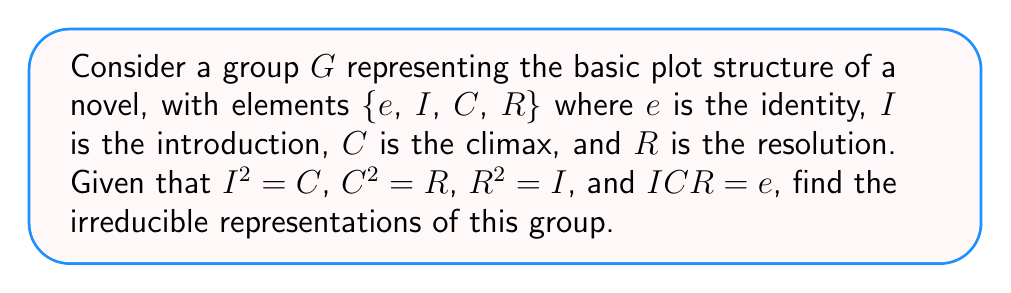Help me with this question. 1) First, we need to determine the order of the group. The group $G$ has 4 elements, so $|G| = 4$.

2) Next, we need to find the conjugacy classes of $G$. Since $G$ is abelian (all elements commute), each element forms its own conjugacy class. So we have 4 conjugacy classes: $\{e\}$, $\{I\}$, $\{C\}$, and $\{R\}$.

3) The number of irreducible representations is equal to the number of conjugacy classes. Therefore, $G$ has 4 irreducible representations.

4) For an abelian group, all irreducible representations are 1-dimensional. This is because the commutator subgroup is trivial.

5) We can construct these representations as follows:
   
   $\chi_1$: The trivial representation, where every element maps to 1.
   
   $\chi_2$: $\chi_2(e) = 1$, $\chi_2(I) = i$, $\chi_2(C) = -1$, $\chi_2(R) = -i$
   
   $\chi_3$: $\chi_3(e) = 1$, $\chi_3(I) = -1$, $\chi_3(C) = 1$, $\chi_3(R) = -1$
   
   $\chi_4$: $\chi_4(e) = 1$, $\chi_4(I) = -i$, $\chi_4(C) = -1$, $\chi_4(R) = i$

6) We can verify that these are indeed representations by checking that they respect the group operations. For example, $\chi_2(I)^2 = i^2 = -1 = \chi_2(C)$, which is consistent with $I^2 = C$.

7) These representations are irreducible because they are 1-dimensional, and thus cannot be further decomposed.
Answer: Four 1-dimensional representations: $\chi_1$, $\chi_2$, $\chi_3$, $\chi_4$ 